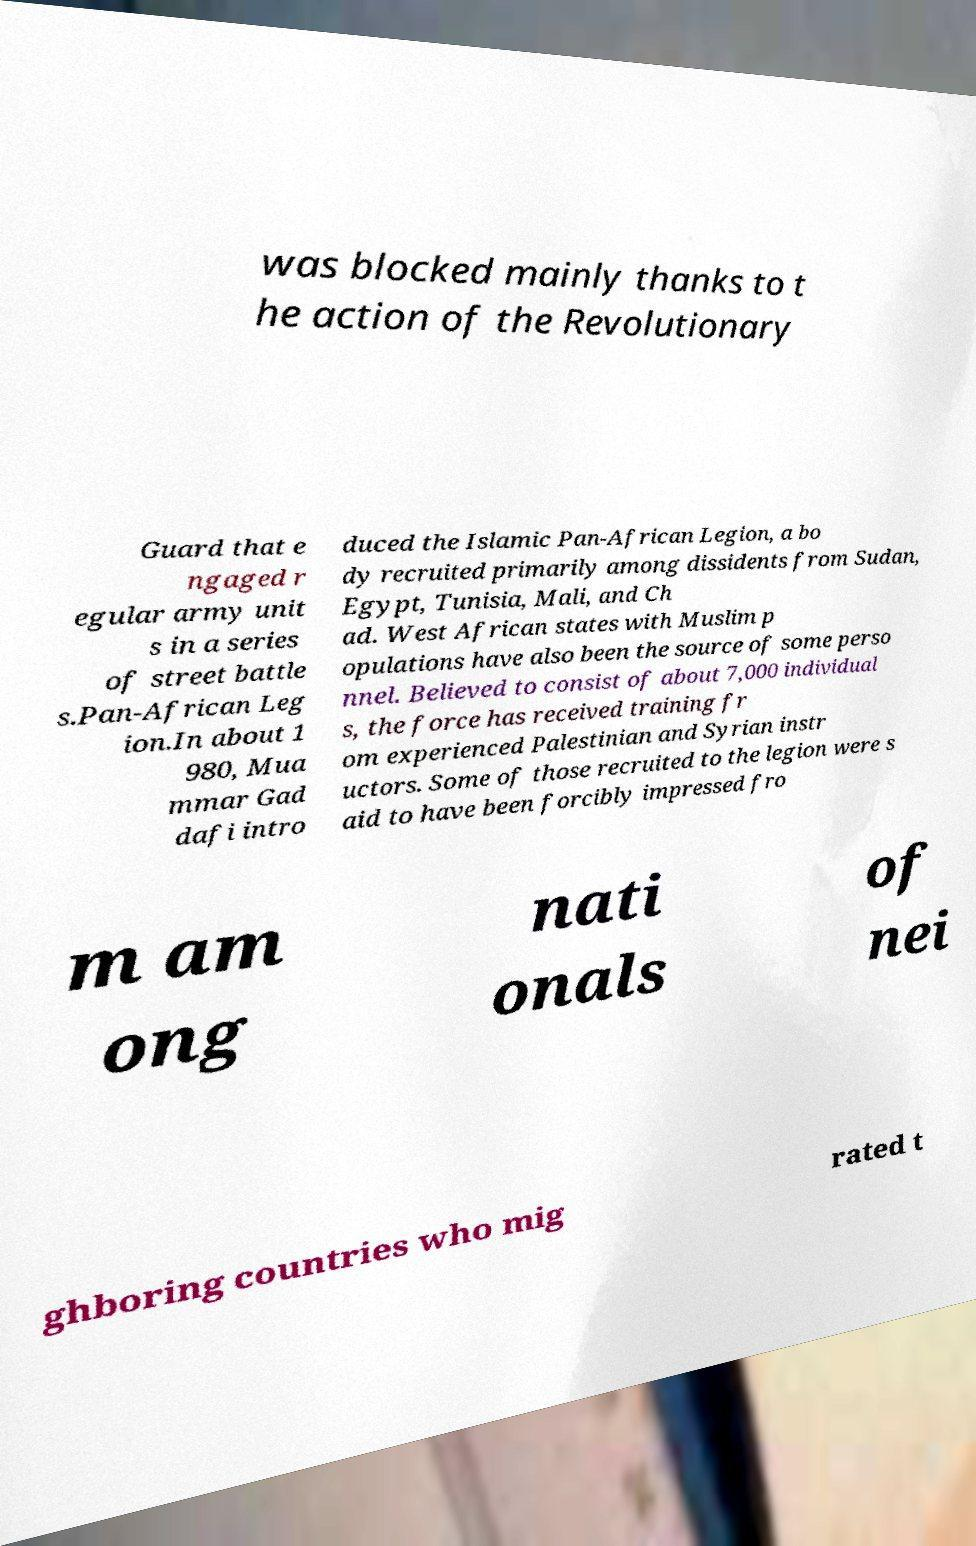Could you assist in decoding the text presented in this image and type it out clearly? was blocked mainly thanks to t he action of the Revolutionary Guard that e ngaged r egular army unit s in a series of street battle s.Pan-African Leg ion.In about 1 980, Mua mmar Gad dafi intro duced the Islamic Pan-African Legion, a bo dy recruited primarily among dissidents from Sudan, Egypt, Tunisia, Mali, and Ch ad. West African states with Muslim p opulations have also been the source of some perso nnel. Believed to consist of about 7,000 individual s, the force has received training fr om experienced Palestinian and Syrian instr uctors. Some of those recruited to the legion were s aid to have been forcibly impressed fro m am ong nati onals of nei ghboring countries who mig rated t 